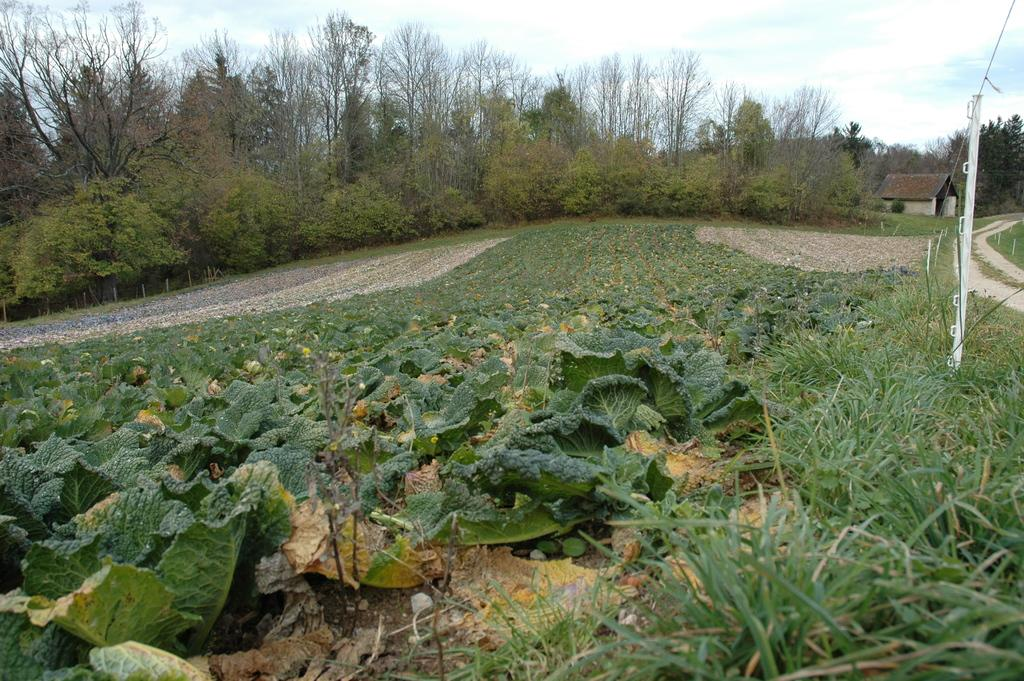How many paths are visible in the image? There are two ways in the image, one on the right side and one on the left side. What structure can be seen on the right side of the image? There is a house on the right side of the image. What can be observed about the surroundings in the image? There is greenery around the area of the image. What type of shame can be seen in the image? There is no shame present in the image; it is a scene with two paths, a house, and greenery. What type of answer is being given in the image? There is no answer being given in the image; it is a visual representation of a scene. 